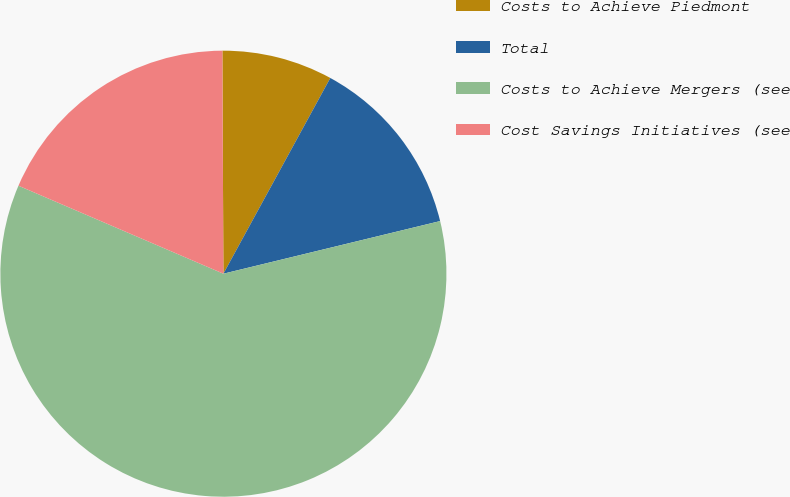Convert chart to OTSL. <chart><loc_0><loc_0><loc_500><loc_500><pie_chart><fcel>Costs to Achieve Piedmont<fcel>Total<fcel>Costs to Achieve Mergers (see<fcel>Cost Savings Initiatives (see<nl><fcel>8.03%<fcel>13.25%<fcel>60.24%<fcel>18.47%<nl></chart> 